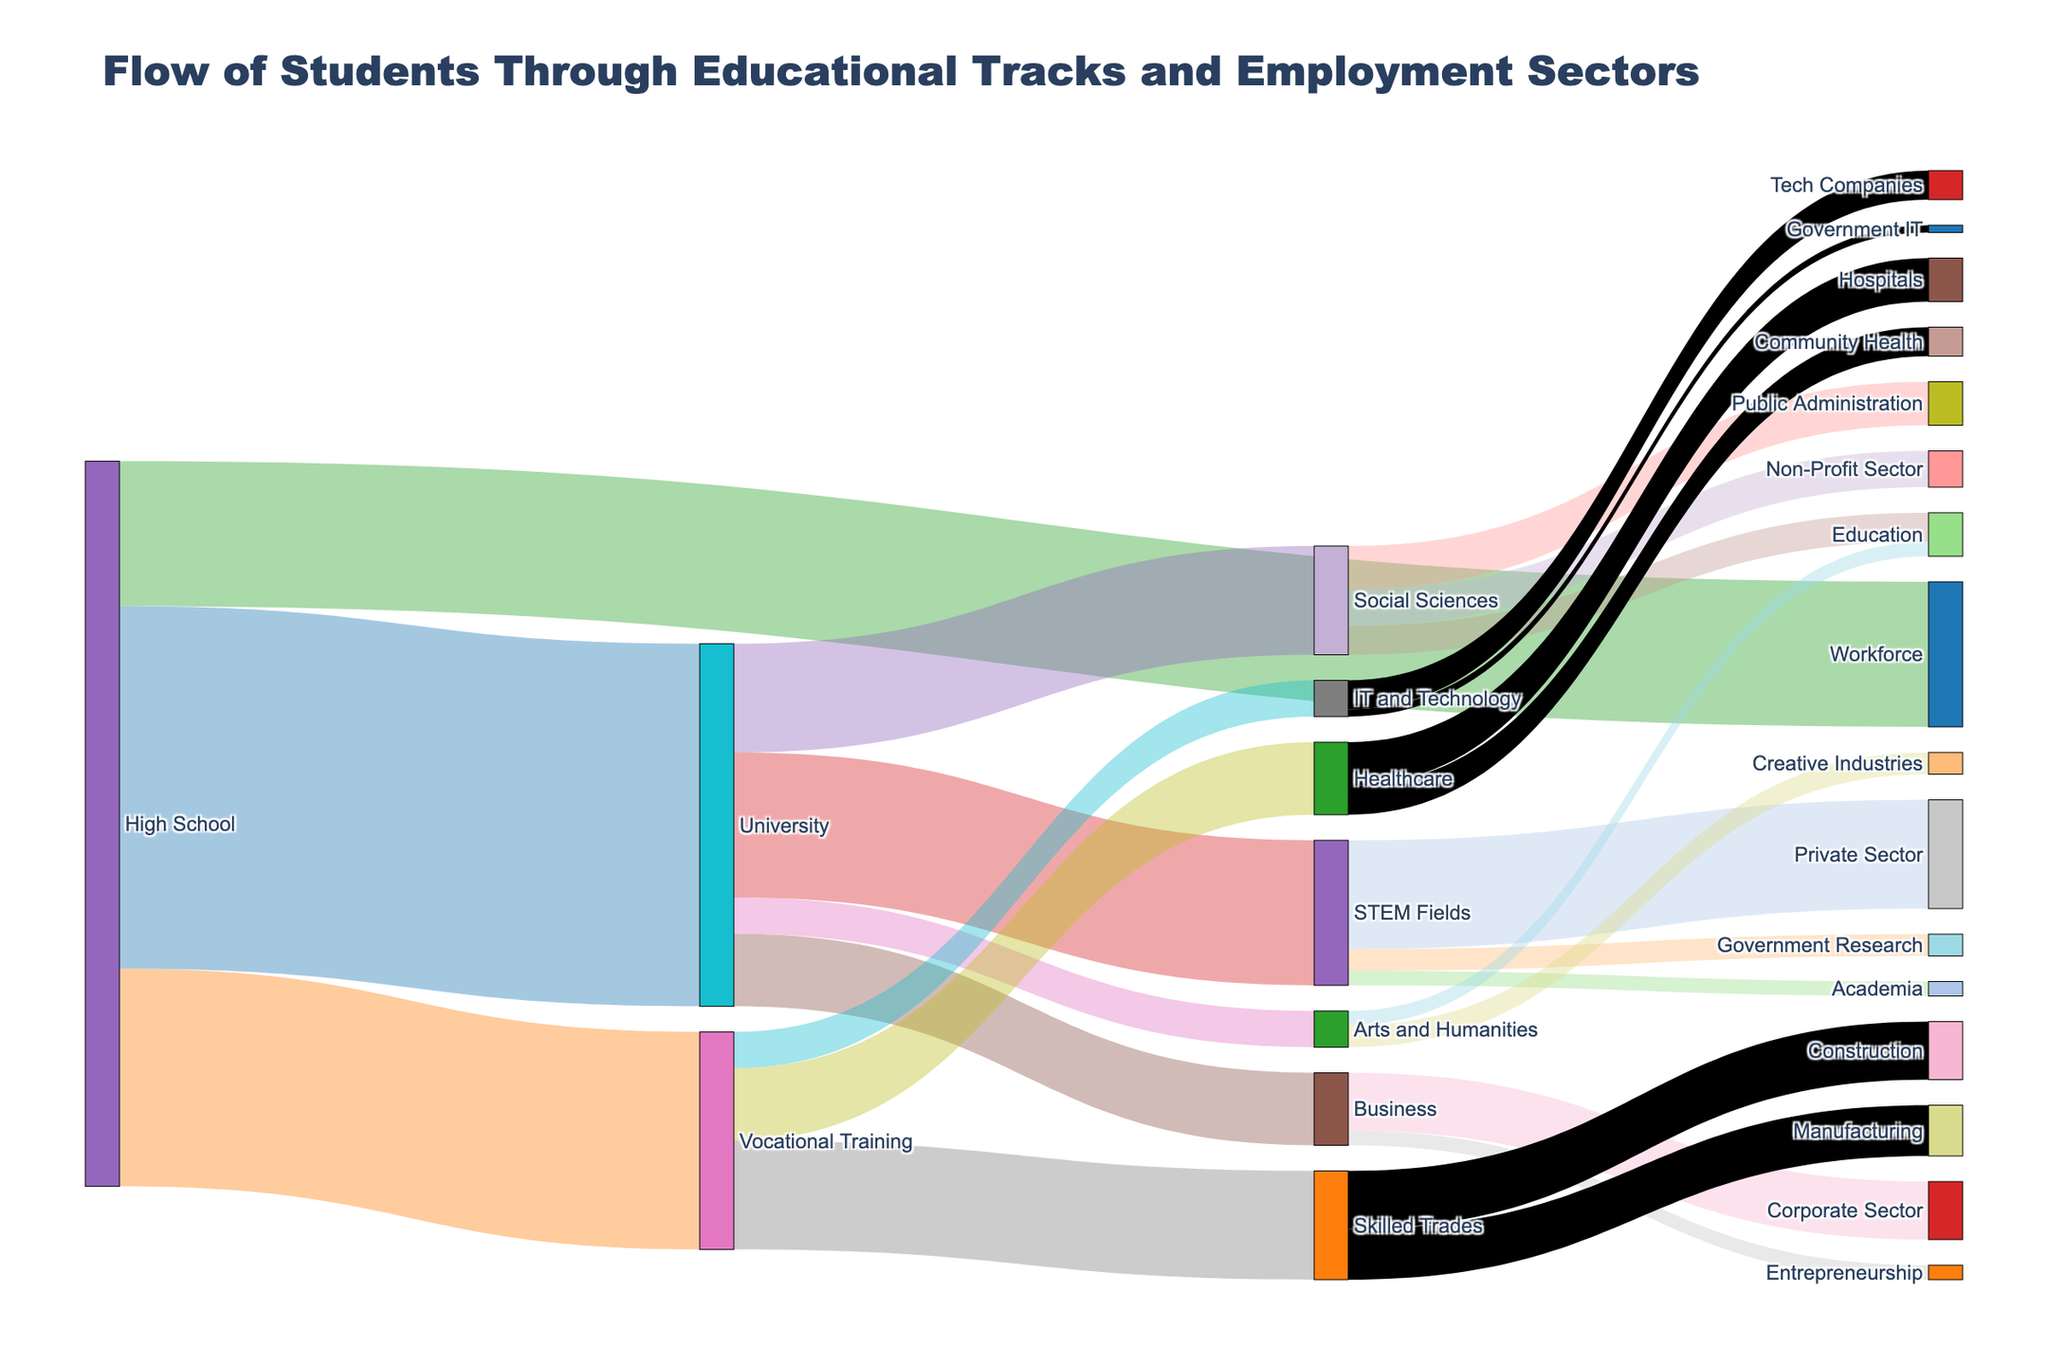what is the title of the figure? The title is usually located at the top of the figure. It provides a brief description of what the figure is about. In this case, it states "Flow of Students Through Educational Tracks and Employment Sectors"
Answer: Flow of Students Through Educational Tracks and Employment Sectors How many students go directly to the workforce after high school? Look for the segment flowing from "High School" to "Workforce" and check the associated value. The value indicates the number of students making this transition.
Answer: 2000 What educational track has the most significant flow of students from high school? Compare the values of flows going from "High School" to various tracks like "University," "Vocational Training," and "Workforce." The track with the highest number is the answer.
Answer: University Which employment sector does the majority of STEM graduates enter? Follow the flow from "STEM Fields" and check which sector, whether "Private Sector," "Government Research," or "Academia," has the highest value.
Answer: Private Sector How many students go from vocational training to the healthcare sector? Identify the flow from "Vocational Training" to "Healthcare" and read the associated value.
Answer: 1000 Compare the number of students entering Social Sciences at the university to those entering Business. Which is higher? Compare the value of the flow from "University" to "Social Sciences" with the flow from "University" to "Business."
Answer: Social Sciences What is the total number of students entering skilled trades from vocational training and what is its relative percentage of the students entering from high school? Sum the values for trades-related sectors (e.g. "Construction" and "Manufacturing") and compare with the total inflow to vocational training. The percentage is calculated as (number of students in trades / students in vocational training) * 100. 
2000 (Vocational Training students to Skilled Trades) 
Percentage calculation: (2000 / 3000) * 100 = 66.67%
Answer: 2000 students, 66.67% 